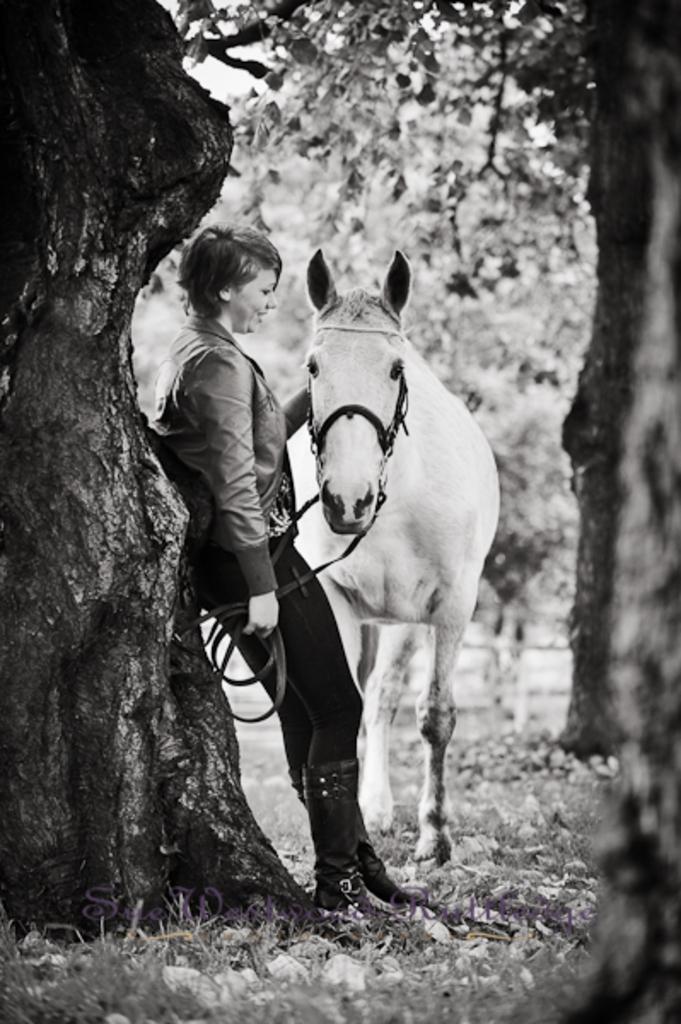Please provide a concise description of this image. This is a white and black picture where we a lady holding a horse and we can see some grass and plants around her. 